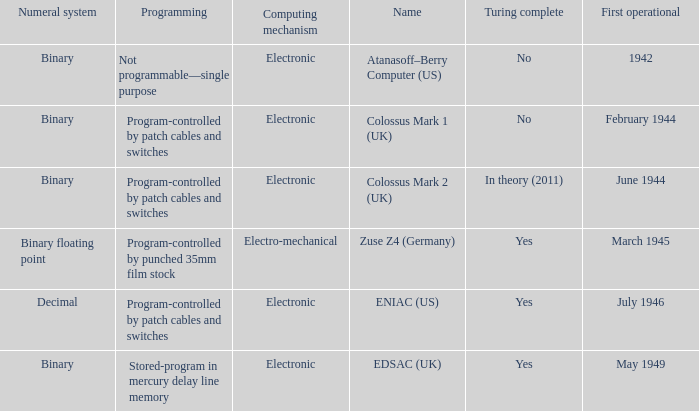What's the turing complete with name being atanasoff–berry computer (us) No. 